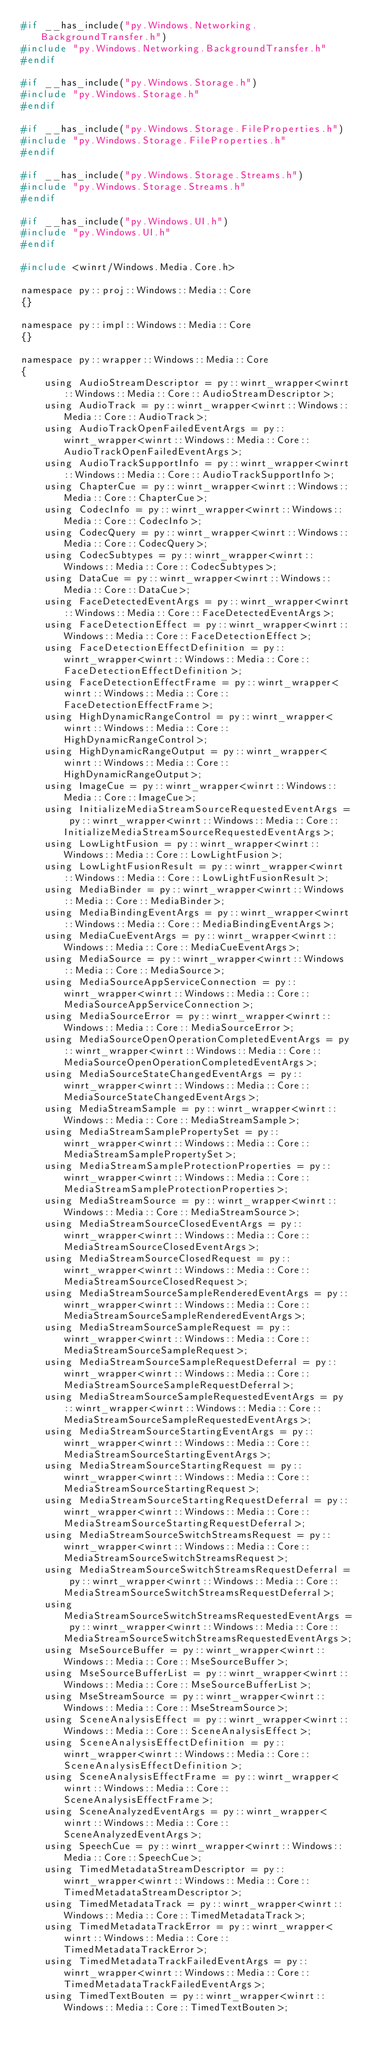Convert code to text. <code><loc_0><loc_0><loc_500><loc_500><_C_>#if __has_include("py.Windows.Networking.BackgroundTransfer.h")
#include "py.Windows.Networking.BackgroundTransfer.h"
#endif

#if __has_include("py.Windows.Storage.h")
#include "py.Windows.Storage.h"
#endif

#if __has_include("py.Windows.Storage.FileProperties.h")
#include "py.Windows.Storage.FileProperties.h"
#endif

#if __has_include("py.Windows.Storage.Streams.h")
#include "py.Windows.Storage.Streams.h"
#endif

#if __has_include("py.Windows.UI.h")
#include "py.Windows.UI.h"
#endif

#include <winrt/Windows.Media.Core.h>

namespace py::proj::Windows::Media::Core
{}

namespace py::impl::Windows::Media::Core
{}

namespace py::wrapper::Windows::Media::Core
{
    using AudioStreamDescriptor = py::winrt_wrapper<winrt::Windows::Media::Core::AudioStreamDescriptor>;
    using AudioTrack = py::winrt_wrapper<winrt::Windows::Media::Core::AudioTrack>;
    using AudioTrackOpenFailedEventArgs = py::winrt_wrapper<winrt::Windows::Media::Core::AudioTrackOpenFailedEventArgs>;
    using AudioTrackSupportInfo = py::winrt_wrapper<winrt::Windows::Media::Core::AudioTrackSupportInfo>;
    using ChapterCue = py::winrt_wrapper<winrt::Windows::Media::Core::ChapterCue>;
    using CodecInfo = py::winrt_wrapper<winrt::Windows::Media::Core::CodecInfo>;
    using CodecQuery = py::winrt_wrapper<winrt::Windows::Media::Core::CodecQuery>;
    using CodecSubtypes = py::winrt_wrapper<winrt::Windows::Media::Core::CodecSubtypes>;
    using DataCue = py::winrt_wrapper<winrt::Windows::Media::Core::DataCue>;
    using FaceDetectedEventArgs = py::winrt_wrapper<winrt::Windows::Media::Core::FaceDetectedEventArgs>;
    using FaceDetectionEffect = py::winrt_wrapper<winrt::Windows::Media::Core::FaceDetectionEffect>;
    using FaceDetectionEffectDefinition = py::winrt_wrapper<winrt::Windows::Media::Core::FaceDetectionEffectDefinition>;
    using FaceDetectionEffectFrame = py::winrt_wrapper<winrt::Windows::Media::Core::FaceDetectionEffectFrame>;
    using HighDynamicRangeControl = py::winrt_wrapper<winrt::Windows::Media::Core::HighDynamicRangeControl>;
    using HighDynamicRangeOutput = py::winrt_wrapper<winrt::Windows::Media::Core::HighDynamicRangeOutput>;
    using ImageCue = py::winrt_wrapper<winrt::Windows::Media::Core::ImageCue>;
    using InitializeMediaStreamSourceRequestedEventArgs = py::winrt_wrapper<winrt::Windows::Media::Core::InitializeMediaStreamSourceRequestedEventArgs>;
    using LowLightFusion = py::winrt_wrapper<winrt::Windows::Media::Core::LowLightFusion>;
    using LowLightFusionResult = py::winrt_wrapper<winrt::Windows::Media::Core::LowLightFusionResult>;
    using MediaBinder = py::winrt_wrapper<winrt::Windows::Media::Core::MediaBinder>;
    using MediaBindingEventArgs = py::winrt_wrapper<winrt::Windows::Media::Core::MediaBindingEventArgs>;
    using MediaCueEventArgs = py::winrt_wrapper<winrt::Windows::Media::Core::MediaCueEventArgs>;
    using MediaSource = py::winrt_wrapper<winrt::Windows::Media::Core::MediaSource>;
    using MediaSourceAppServiceConnection = py::winrt_wrapper<winrt::Windows::Media::Core::MediaSourceAppServiceConnection>;
    using MediaSourceError = py::winrt_wrapper<winrt::Windows::Media::Core::MediaSourceError>;
    using MediaSourceOpenOperationCompletedEventArgs = py::winrt_wrapper<winrt::Windows::Media::Core::MediaSourceOpenOperationCompletedEventArgs>;
    using MediaSourceStateChangedEventArgs = py::winrt_wrapper<winrt::Windows::Media::Core::MediaSourceStateChangedEventArgs>;
    using MediaStreamSample = py::winrt_wrapper<winrt::Windows::Media::Core::MediaStreamSample>;
    using MediaStreamSamplePropertySet = py::winrt_wrapper<winrt::Windows::Media::Core::MediaStreamSamplePropertySet>;
    using MediaStreamSampleProtectionProperties = py::winrt_wrapper<winrt::Windows::Media::Core::MediaStreamSampleProtectionProperties>;
    using MediaStreamSource = py::winrt_wrapper<winrt::Windows::Media::Core::MediaStreamSource>;
    using MediaStreamSourceClosedEventArgs = py::winrt_wrapper<winrt::Windows::Media::Core::MediaStreamSourceClosedEventArgs>;
    using MediaStreamSourceClosedRequest = py::winrt_wrapper<winrt::Windows::Media::Core::MediaStreamSourceClosedRequest>;
    using MediaStreamSourceSampleRenderedEventArgs = py::winrt_wrapper<winrt::Windows::Media::Core::MediaStreamSourceSampleRenderedEventArgs>;
    using MediaStreamSourceSampleRequest = py::winrt_wrapper<winrt::Windows::Media::Core::MediaStreamSourceSampleRequest>;
    using MediaStreamSourceSampleRequestDeferral = py::winrt_wrapper<winrt::Windows::Media::Core::MediaStreamSourceSampleRequestDeferral>;
    using MediaStreamSourceSampleRequestedEventArgs = py::winrt_wrapper<winrt::Windows::Media::Core::MediaStreamSourceSampleRequestedEventArgs>;
    using MediaStreamSourceStartingEventArgs = py::winrt_wrapper<winrt::Windows::Media::Core::MediaStreamSourceStartingEventArgs>;
    using MediaStreamSourceStartingRequest = py::winrt_wrapper<winrt::Windows::Media::Core::MediaStreamSourceStartingRequest>;
    using MediaStreamSourceStartingRequestDeferral = py::winrt_wrapper<winrt::Windows::Media::Core::MediaStreamSourceStartingRequestDeferral>;
    using MediaStreamSourceSwitchStreamsRequest = py::winrt_wrapper<winrt::Windows::Media::Core::MediaStreamSourceSwitchStreamsRequest>;
    using MediaStreamSourceSwitchStreamsRequestDeferral = py::winrt_wrapper<winrt::Windows::Media::Core::MediaStreamSourceSwitchStreamsRequestDeferral>;
    using MediaStreamSourceSwitchStreamsRequestedEventArgs = py::winrt_wrapper<winrt::Windows::Media::Core::MediaStreamSourceSwitchStreamsRequestedEventArgs>;
    using MseSourceBuffer = py::winrt_wrapper<winrt::Windows::Media::Core::MseSourceBuffer>;
    using MseSourceBufferList = py::winrt_wrapper<winrt::Windows::Media::Core::MseSourceBufferList>;
    using MseStreamSource = py::winrt_wrapper<winrt::Windows::Media::Core::MseStreamSource>;
    using SceneAnalysisEffect = py::winrt_wrapper<winrt::Windows::Media::Core::SceneAnalysisEffect>;
    using SceneAnalysisEffectDefinition = py::winrt_wrapper<winrt::Windows::Media::Core::SceneAnalysisEffectDefinition>;
    using SceneAnalysisEffectFrame = py::winrt_wrapper<winrt::Windows::Media::Core::SceneAnalysisEffectFrame>;
    using SceneAnalyzedEventArgs = py::winrt_wrapper<winrt::Windows::Media::Core::SceneAnalyzedEventArgs>;
    using SpeechCue = py::winrt_wrapper<winrt::Windows::Media::Core::SpeechCue>;
    using TimedMetadataStreamDescriptor = py::winrt_wrapper<winrt::Windows::Media::Core::TimedMetadataStreamDescriptor>;
    using TimedMetadataTrack = py::winrt_wrapper<winrt::Windows::Media::Core::TimedMetadataTrack>;
    using TimedMetadataTrackError = py::winrt_wrapper<winrt::Windows::Media::Core::TimedMetadataTrackError>;
    using TimedMetadataTrackFailedEventArgs = py::winrt_wrapper<winrt::Windows::Media::Core::TimedMetadataTrackFailedEventArgs>;
    using TimedTextBouten = py::winrt_wrapper<winrt::Windows::Media::Core::TimedTextBouten>;</code> 